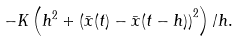<formula> <loc_0><loc_0><loc_500><loc_500>- K \left ( h ^ { 2 } + \left ( \bar { x } ( t ) - \bar { x } ( t - h ) \right ) ^ { 2 } \right ) / h .</formula> 